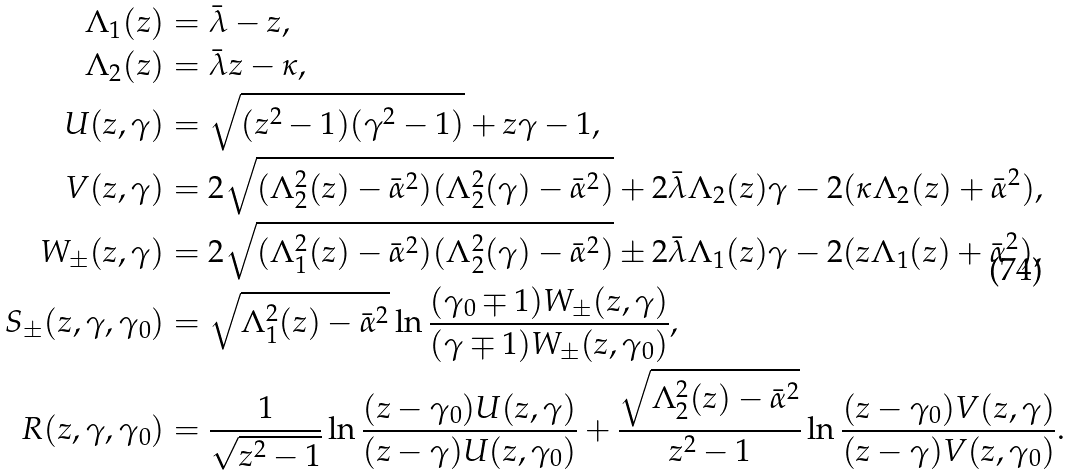<formula> <loc_0><loc_0><loc_500><loc_500>\Lambda _ { 1 } ( z ) & = \bar { \lambda } - z , \\ \Lambda _ { 2 } ( z ) & = \bar { \lambda } z - \kappa , \\ U ( z , \gamma ) & = \sqrt { ( z ^ { 2 } - 1 ) ( \gamma ^ { 2 } - 1 ) } + z \gamma - 1 , \\ V ( z , \gamma ) & = 2 \sqrt { ( \Lambda _ { 2 } ^ { 2 } ( z ) - \bar { \alpha } ^ { 2 } ) ( \Lambda _ { 2 } ^ { 2 } ( \gamma ) - \bar { \alpha } ^ { 2 } ) } + 2 \bar { \lambda } \Lambda _ { 2 } ( z ) \gamma - 2 ( \kappa \Lambda _ { 2 } ( z ) + \bar { \alpha } ^ { 2 } ) , \\ W _ { \pm } ( z , \gamma ) & = 2 \sqrt { ( \Lambda _ { 1 } ^ { 2 } ( z ) - \bar { \alpha } ^ { 2 } ) ( \Lambda _ { 2 } ^ { 2 } ( \gamma ) - \bar { \alpha } ^ { 2 } ) } \pm 2 \bar { \lambda } \Lambda _ { 1 } ( z ) \gamma - 2 ( z \Lambda _ { 1 } ( z ) + \bar { \alpha } ^ { 2 } ) , \\ S _ { \pm } ( z , \gamma , \gamma _ { 0 } ) & = \sqrt { \Lambda _ { 1 } ^ { 2 } ( z ) - \bar { \alpha } ^ { 2 } } \ln \frac { ( \gamma _ { 0 } \mp 1 ) W _ { \pm } ( z , \gamma ) } { ( \gamma \mp 1 ) W _ { \pm } ( z , \gamma _ { 0 } ) } , \\ R ( z , \gamma , \gamma _ { 0 } ) & = \frac { 1 } { \sqrt { z ^ { 2 } - 1 } } \ln \frac { ( z - \gamma _ { 0 } ) U ( z , \gamma ) } { ( z - \gamma ) U ( z , \gamma _ { 0 } ) } + \frac { \sqrt { \Lambda _ { 2 } ^ { 2 } ( z ) - \bar { \alpha } ^ { 2 } } } { z ^ { 2 } - 1 } \ln \frac { ( z - \gamma _ { 0 } ) V ( z , \gamma ) } { ( z - \gamma ) V ( z , \gamma _ { 0 } ) } .</formula> 